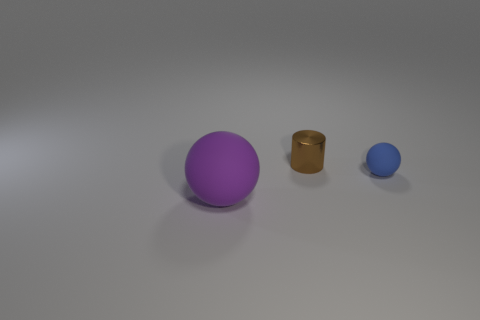Add 2 tiny blue balls. How many objects exist? 5 Subtract all cylinders. How many objects are left? 2 Subtract all purple rubber balls. Subtract all large blue rubber cylinders. How many objects are left? 2 Add 1 purple spheres. How many purple spheres are left? 2 Add 2 tiny rubber spheres. How many tiny rubber spheres exist? 3 Subtract 0 red cylinders. How many objects are left? 3 